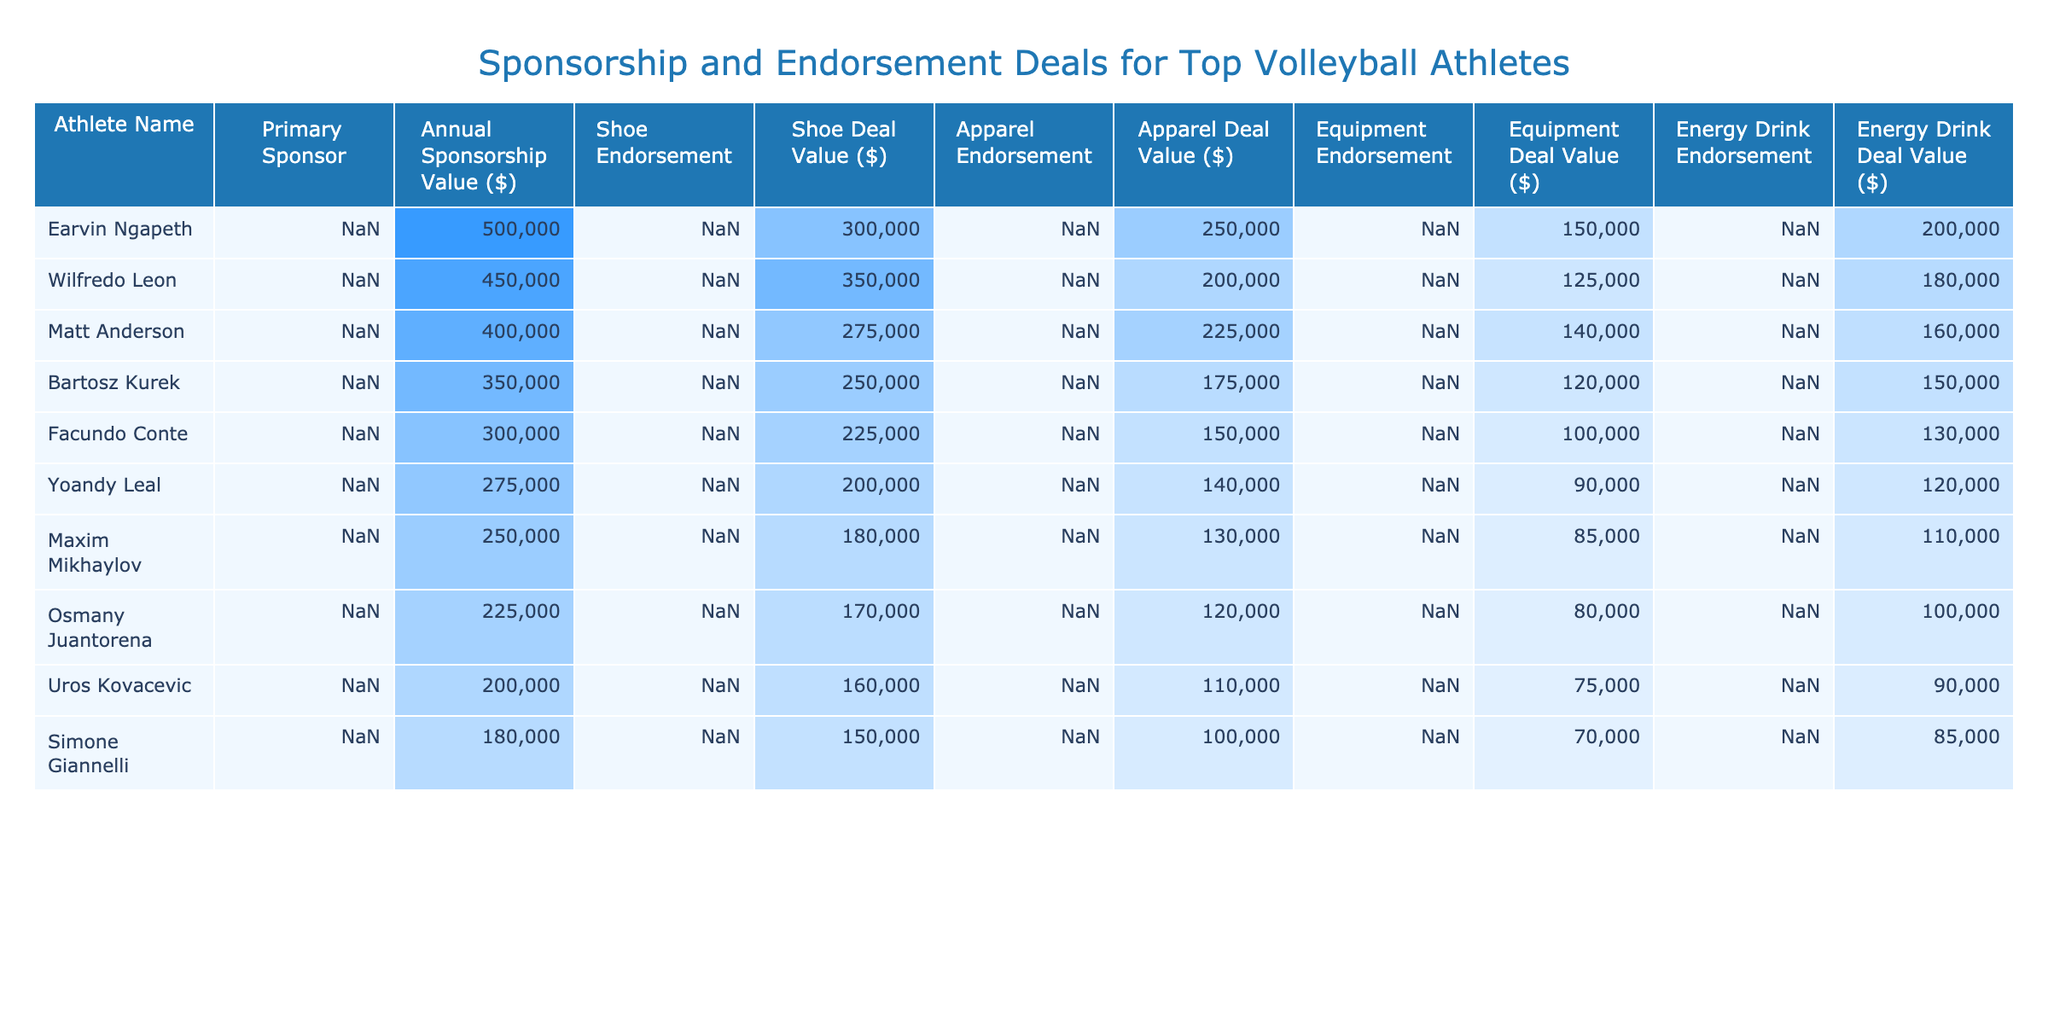What is the total annual sponsorship value for Earvin Ngapeth? Earvin Ngapeth's annual sponsorship value is listed as $500,000 in the table.
Answer: 500000 Which athlete has the highest total endorsement values from shoes, apparel, equipment, and energy drinks? To find the total endorsement value for each athlete, add the respective deal values: Earvin Ngapeth: 300000 + 250000 + 150000 + 200000 = 900000; Wilfredo Leon: 350000 + 200000 + 125000 + 180000 = 855000; Matt Anderson: 275000 + 225000 + 140000 + 160000 = 800000; and so on. The highest is Earvin Ngapeth with $900,000.
Answer: Earvin Ngapeth What is the total annual sponsorship value of all athletes combined? Adding up all the annual sponsorship values from the table: 500000 + 450000 + 400000 + 350000 + 300000 + 275000 + 250000 + 225000 + 200000 + 180000 = 3130000.
Answer: 3130000 Is Matt Anderson sponsored by the same brand for both his shoe and apparel endorsements? According to the table, Matt Anderson is sponsored by Under Armour for both shoe and apparel endorsements, indicating that the statement is true.
Answer: Yes Which athlete has the lowest total value from endorsements across all categories? To calculate the total value for each athlete, sum their deal values across shoes, apparel, equipment, and energy drinks. The totals are as follows: Maxim Mikhaylov: 180000 + 130000 + 85000 + 110000 = 505000; Osmany Juantorena: 170000 + 120000 + 80000 + 100000 = 470000; Uros Kovacevic: 160000 + 110000 + 75000 + 90000 = 435000, and so on. The lowest total comes from Uros Kovacevic with $435,000.
Answer: Uros Kovacevic What percentage of Wilfredo Leon's total endorsement value comes from his primary sponsorship? First, calculate Wilfredo Leon's total endorsement value: 350000 + 200000 + 125000 + 180000 = 855000. His annual sponsorship value is $450,000. Now, calculate the percentage: (450000/855000) * 100 = 52.7%.
Answer: 52.7% What is the average shoe deal value among all listed athletes? The shoe deal values are: 300000, 350000, 275000, 250000, 225000, 200000, 180000, 170000, 160000, 150000. Adding those gives 2,895,000. Dividing by 10 athletes gives an average of 289500.
Answer: 289500 Does any athlete have more than one endorsement with the same brand? Examining the table reveals that Matt Anderson has both shoe and apparel endorsements with Under Armour, confirming that yes, there is an athlete with multiple endorsements from the same brand.
Answer: Yes 